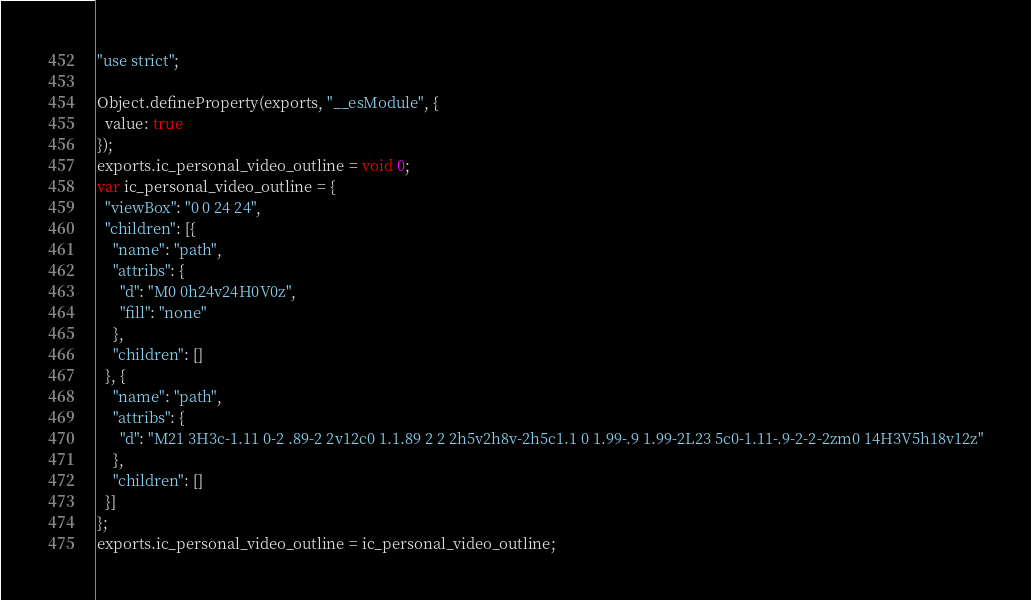<code> <loc_0><loc_0><loc_500><loc_500><_JavaScript_>"use strict";

Object.defineProperty(exports, "__esModule", {
  value: true
});
exports.ic_personal_video_outline = void 0;
var ic_personal_video_outline = {
  "viewBox": "0 0 24 24",
  "children": [{
    "name": "path",
    "attribs": {
      "d": "M0 0h24v24H0V0z",
      "fill": "none"
    },
    "children": []
  }, {
    "name": "path",
    "attribs": {
      "d": "M21 3H3c-1.11 0-2 .89-2 2v12c0 1.1.89 2 2 2h5v2h8v-2h5c1.1 0 1.99-.9 1.99-2L23 5c0-1.11-.9-2-2-2zm0 14H3V5h18v12z"
    },
    "children": []
  }]
};
exports.ic_personal_video_outline = ic_personal_video_outline;</code> 